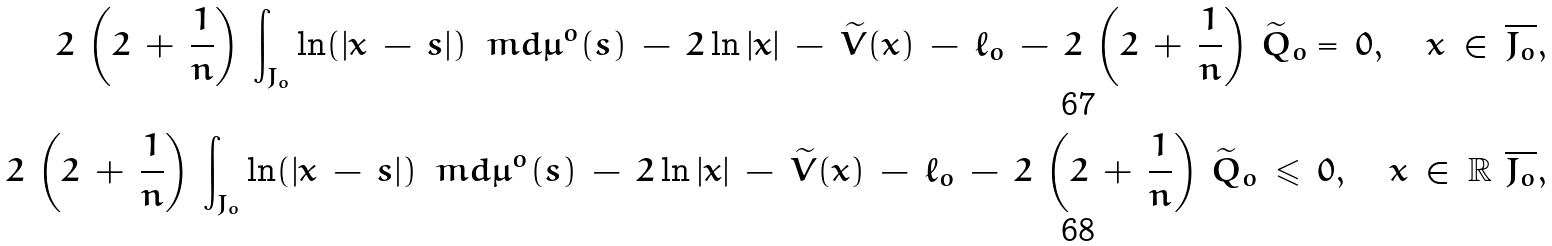<formula> <loc_0><loc_0><loc_500><loc_500>2 \, \left ( 2 \, + \, \frac { 1 } { n } \right ) \, \int _ { J _ { o } } \ln ( | x \, - \, s | ) \, \ m d \mu ^ { o } ( s ) \, - \, 2 \ln | x | \, - \, \widetilde { V } ( x ) \, - \, \ell _ { o } \, - \, 2 \, \left ( 2 \, + \, \frac { 1 } { n } \right ) \, \widetilde { Q } _ { o } = \, 0 , \quad x \, \in \, \overline { J _ { o } } , \\ 2 \, \left ( 2 \, + \, \frac { 1 } { n } \right ) \, \int _ { J _ { o } } \ln ( | x \, - \, s | ) \, \ m d \mu ^ { o } ( s ) \, - \, 2 \ln | x | \, - \, \widetilde { V } ( x ) \, - \, \ell _ { o } \, - \, 2 \, \left ( 2 \, + \, \frac { 1 } { n } \right ) \, \widetilde { Q } _ { o } \, \leqslant \, 0 , \quad x \, \in \, \mathbb { R } \ \overline { J _ { o } } ,</formula> 